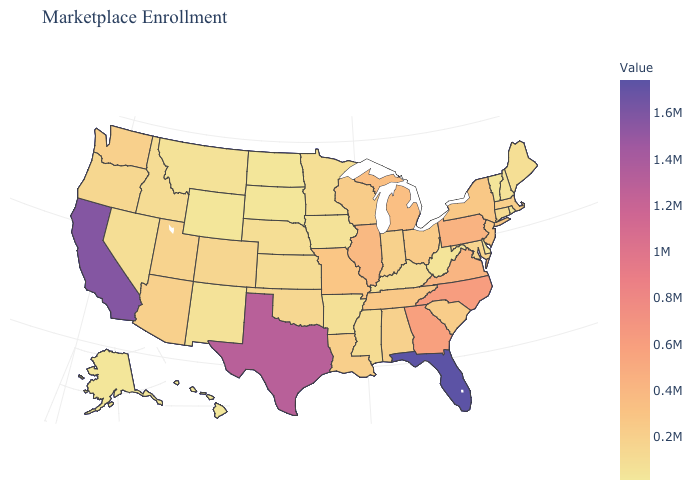Which states have the highest value in the USA?
Short answer required. Florida. Does New Mexico have a higher value than New York?
Answer briefly. No. Does Hawaii have the lowest value in the USA?
Give a very brief answer. Yes. 